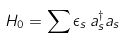<formula> <loc_0><loc_0><loc_500><loc_500>H _ { 0 } = \sum \epsilon _ { s } \, a _ { s } ^ { \dagger } a _ { s }</formula> 